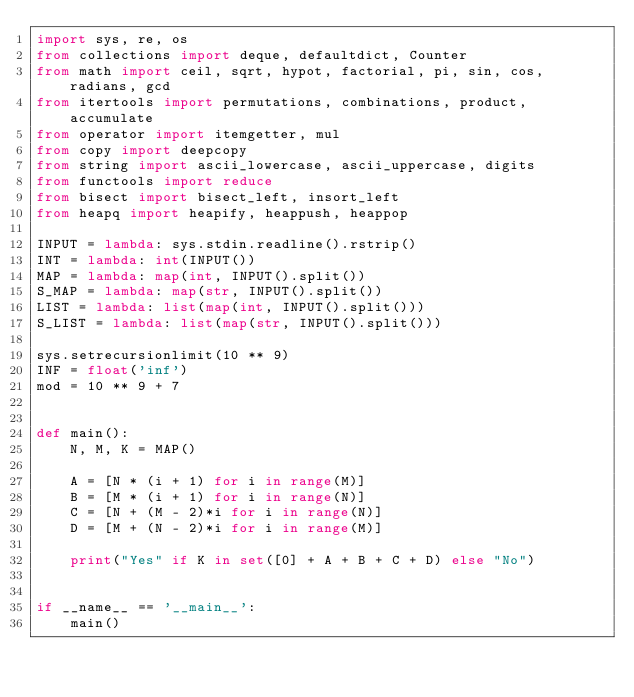Convert code to text. <code><loc_0><loc_0><loc_500><loc_500><_Python_>import sys, re, os
from collections import deque, defaultdict, Counter
from math import ceil, sqrt, hypot, factorial, pi, sin, cos, radians, gcd
from itertools import permutations, combinations, product, accumulate
from operator import itemgetter, mul
from copy import deepcopy
from string import ascii_lowercase, ascii_uppercase, digits
from functools import reduce
from bisect import bisect_left, insort_left
from heapq import heapify, heappush, heappop

INPUT = lambda: sys.stdin.readline().rstrip()
INT = lambda: int(INPUT())
MAP = lambda: map(int, INPUT().split())
S_MAP = lambda: map(str, INPUT().split())
LIST = lambda: list(map(int, INPUT().split()))
S_LIST = lambda: list(map(str, INPUT().split()))

sys.setrecursionlimit(10 ** 9)
INF = float('inf')
mod = 10 ** 9 + 7


def main():
    N, M, K = MAP()

    A = [N * (i + 1) for i in range(M)]
    B = [M * (i + 1) for i in range(N)]
    C = [N + (M - 2)*i for i in range(N)]
    D = [M + (N - 2)*i for i in range(M)]

    print("Yes" if K in set([0] + A + B + C + D) else "No")


if __name__ == '__main__':
    main()</code> 